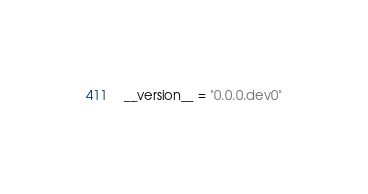Convert code to text. <code><loc_0><loc_0><loc_500><loc_500><_Python_>__version__ = "0.0.0.dev0"

</code> 